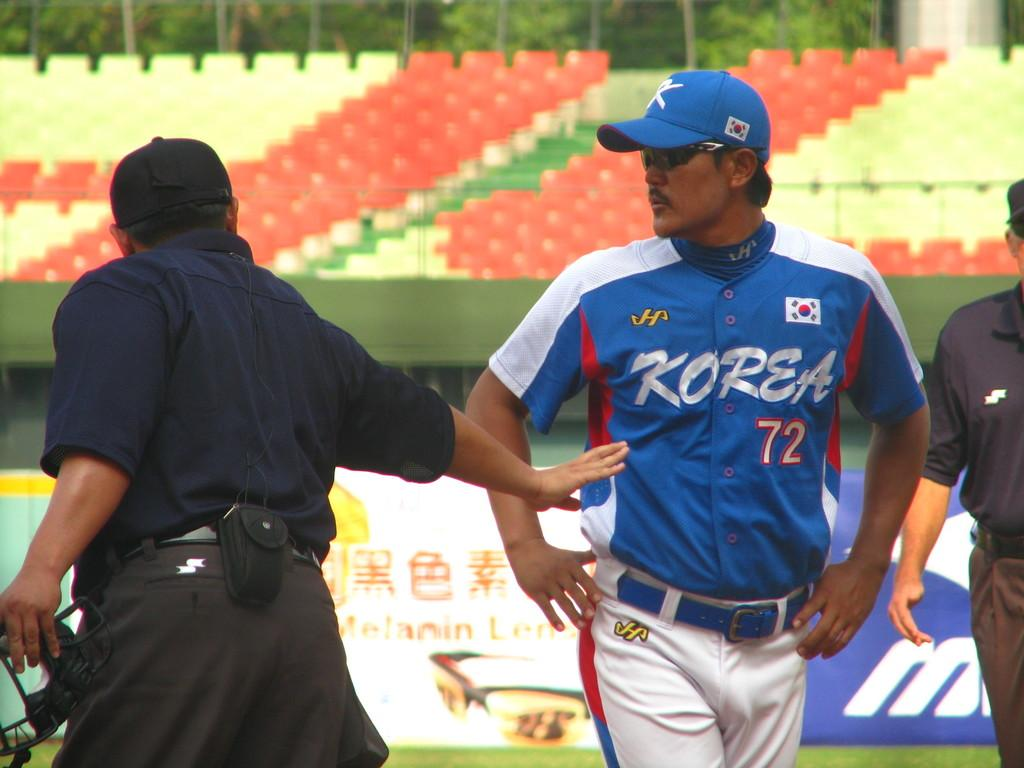<image>
Give a short and clear explanation of the subsequent image. A baseball player from the Korean team looking at the umpire. 